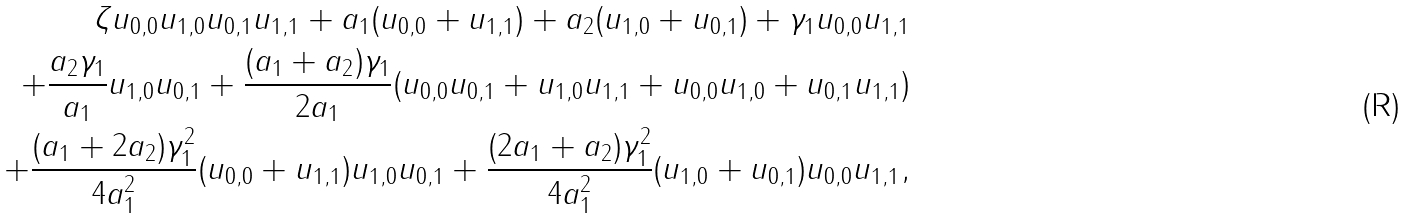Convert formula to latex. <formula><loc_0><loc_0><loc_500><loc_500>\zeta u _ { 0 , 0 } u _ { 1 , 0 } u _ { 0 , 1 } u _ { 1 , 1 } + a _ { 1 } ( u _ { 0 , 0 } + u _ { 1 , 1 } ) + a _ { 2 } ( u _ { 1 , 0 } + u _ { 0 , 1 } ) + \gamma _ { 1 } u _ { 0 , 0 } u _ { 1 , 1 } \\ + \frac { a _ { 2 } \gamma _ { 1 } } { a _ { 1 } } u _ { 1 , 0 } u _ { 0 , 1 } + \frac { ( a _ { 1 } + a _ { 2 } ) \gamma _ { 1 } } { 2 a _ { 1 } } ( u _ { 0 , 0 } u _ { 0 , 1 } + u _ { 1 , 0 } u _ { 1 , 1 } + u _ { 0 , 0 } u _ { 1 , 0 } + u _ { 0 , 1 } u _ { 1 , 1 } ) \\ + \frac { ( a _ { 1 } + 2 a _ { 2 } ) \gamma _ { 1 } ^ { 2 } } { 4 a _ { 1 } ^ { 2 } } ( u _ { 0 , 0 } + u _ { 1 , 1 } ) u _ { 1 , 0 } u _ { 0 , 1 } + \frac { ( 2 a _ { 1 } + a _ { 2 } ) \gamma _ { 1 } ^ { 2 } } { 4 a _ { 1 } ^ { 2 } } ( u _ { 1 , 0 } + u _ { 0 , 1 } ) u _ { 0 , 0 } u _ { 1 , 1 } ,</formula> 